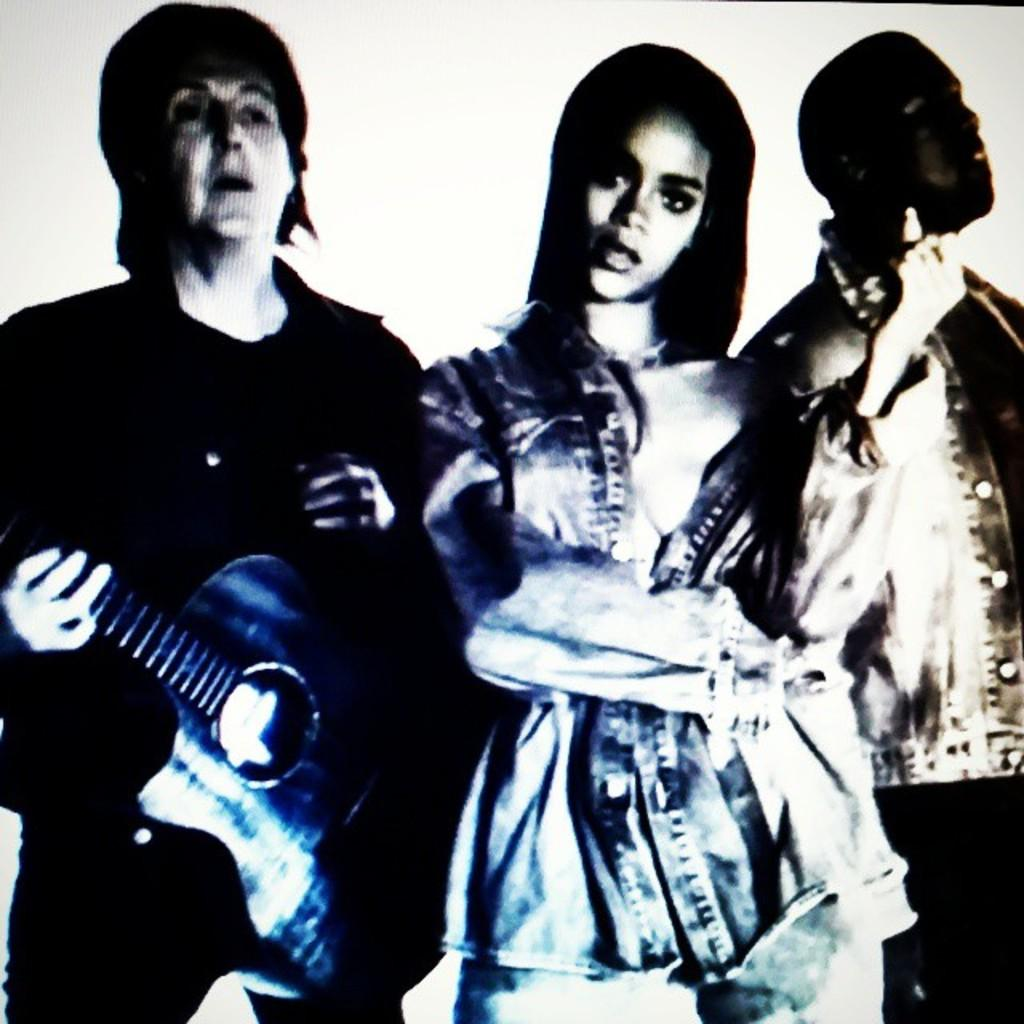How many people are present in the image? There are three people in the image. What is one of the people holding? One of the people is holding a guitar. What type of throne is visible in the image? There is no throne present in the image. How many snails can be seen crawling on the guitar in the image? There are no snails visible in the image, and the guitar is not being used by any snails. 